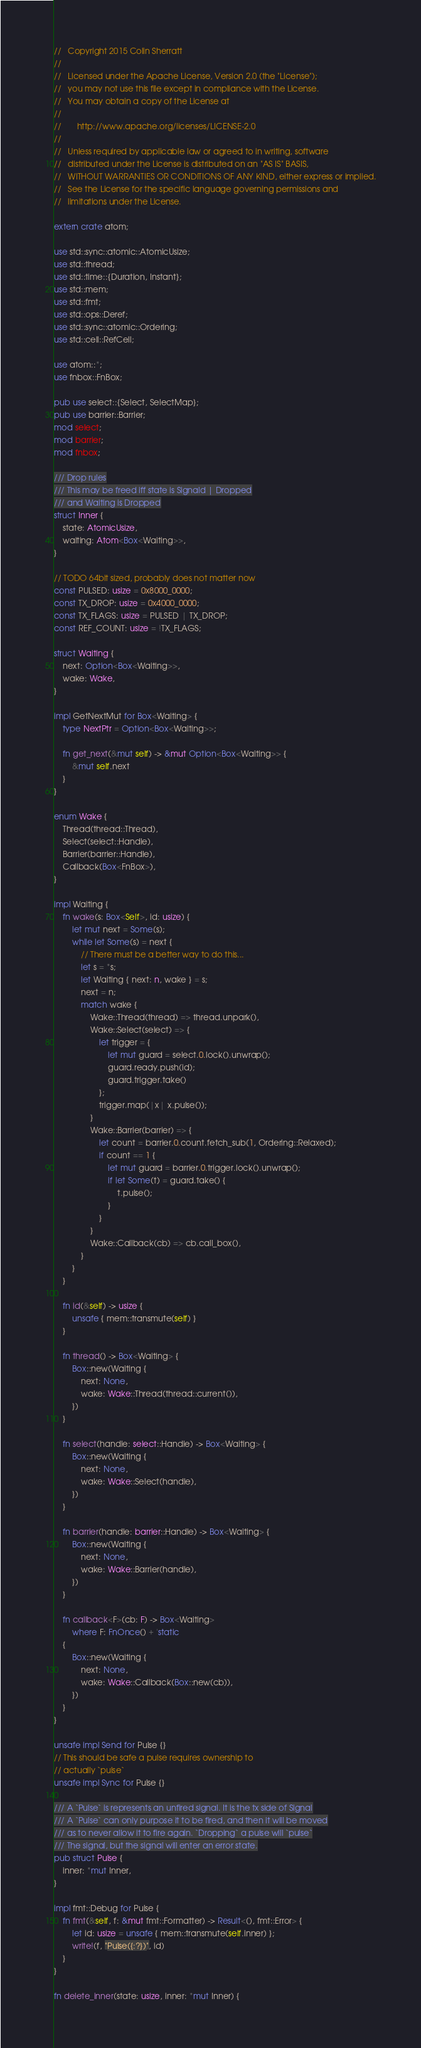<code> <loc_0><loc_0><loc_500><loc_500><_Rust_>//   Copyright 2015 Colin Sherratt
//
//   Licensed under the Apache License, Version 2.0 (the "License");
//   you may not use this file except in compliance with the License.
//   You may obtain a copy of the License at
//
//       http://www.apache.org/licenses/LICENSE-2.0
//
//   Unless required by applicable law or agreed to in writing, software
//   distributed under the License is distributed on an "AS IS" BASIS,
//   WITHOUT WARRANTIES OR CONDITIONS OF ANY KIND, either express or implied.
//   See the License for the specific language governing permissions and
//   limitations under the License.

extern crate atom;

use std::sync::atomic::AtomicUsize;
use std::thread;
use std::time::{Duration, Instant};
use std::mem;
use std::fmt;
use std::ops::Deref;
use std::sync::atomic::Ordering;
use std::cell::RefCell;

use atom::*;
use fnbox::FnBox;

pub use select::{Select, SelectMap};
pub use barrier::Barrier;
mod select;
mod barrier;
mod fnbox;

/// Drop rules
/// This may be freed iff state is Signald | Dropped
/// and Waiting is Dropped
struct Inner {
    state: AtomicUsize,
    waiting: Atom<Box<Waiting>>,
}

// TODO 64bit sized, probably does not matter now
const PULSED: usize = 0x8000_0000;
const TX_DROP: usize = 0x4000_0000;
const TX_FLAGS: usize = PULSED | TX_DROP;
const REF_COUNT: usize = !TX_FLAGS;

struct Waiting {
    next: Option<Box<Waiting>>,
    wake: Wake,
}

impl GetNextMut for Box<Waiting> {
    type NextPtr = Option<Box<Waiting>>;

    fn get_next(&mut self) -> &mut Option<Box<Waiting>> {
        &mut self.next
    }
}

enum Wake {
    Thread(thread::Thread),
    Select(select::Handle),
    Barrier(barrier::Handle),
    Callback(Box<FnBox>),
}

impl Waiting {
    fn wake(s: Box<Self>, id: usize) {
        let mut next = Some(s);
        while let Some(s) = next {
            // There must be a better way to do this...
            let s = *s;
            let Waiting { next: n, wake } = s;
            next = n;
            match wake {
                Wake::Thread(thread) => thread.unpark(),
                Wake::Select(select) => {
                    let trigger = {
                        let mut guard = select.0.lock().unwrap();
                        guard.ready.push(id);
                        guard.trigger.take()
                    };
                    trigger.map(|x| x.pulse());
                }
                Wake::Barrier(barrier) => {
                    let count = barrier.0.count.fetch_sub(1, Ordering::Relaxed);
                    if count == 1 {
                        let mut guard = barrier.0.trigger.lock().unwrap();
                        if let Some(t) = guard.take() {
                            t.pulse();
                        }
                    }
                }
                Wake::Callback(cb) => cb.call_box(),
            }
        }
    }

    fn id(&self) -> usize {
        unsafe { mem::transmute(self) }
    }

    fn thread() -> Box<Waiting> {
        Box::new(Waiting {
            next: None,
            wake: Wake::Thread(thread::current()),
        })
    }

    fn select(handle: select::Handle) -> Box<Waiting> {
        Box::new(Waiting {
            next: None,
            wake: Wake::Select(handle),
        })
    }

    fn barrier(handle: barrier::Handle) -> Box<Waiting> {
        Box::new(Waiting {
            next: None,
            wake: Wake::Barrier(handle),
        })
    }

    fn callback<F>(cb: F) -> Box<Waiting>
        where F: FnOnce() + 'static
    {
        Box::new(Waiting {
            next: None,
            wake: Wake::Callback(Box::new(cb)),
        })
    }
}

unsafe impl Send for Pulse {}
// This should be safe a pulse requires ownership to
// actually `pulse`
unsafe impl Sync for Pulse {}

/// A `Pulse` is represents an unfired signal. It is the tx side of Signal
/// A `Pulse` can only purpose it to be fired, and then it will be moved
/// as to never allow it to fire again. `Dropping` a pulse will `pulse`
/// The signal, but the signal will enter an error state.
pub struct Pulse {
    inner: *mut Inner,
}

impl fmt::Debug for Pulse {
    fn fmt(&self, f: &mut fmt::Formatter) -> Result<(), fmt::Error> {
        let id: usize = unsafe { mem::transmute(self.inner) };
        write!(f, "Pulse({:?})", id)
    }
}

fn delete_inner(state: usize, inner: *mut Inner) {</code> 